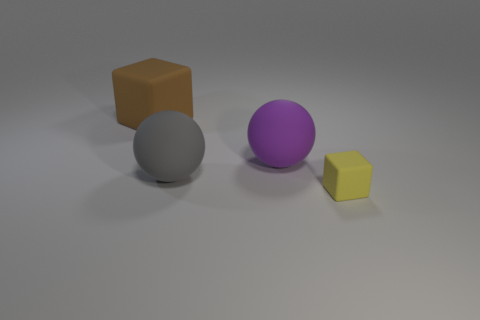Add 1 green metal cylinders. How many objects exist? 5 Subtract all purple balls. How many balls are left? 1 Subtract 1 spheres. How many spheres are left? 1 Add 4 rubber things. How many rubber things are left? 8 Add 1 cyan cylinders. How many cyan cylinders exist? 1 Subtract 0 yellow balls. How many objects are left? 4 Subtract all brown balls. Subtract all red blocks. How many balls are left? 2 Subtract all brown cylinders. How many cyan spheres are left? 0 Subtract all purple matte cylinders. Subtract all purple matte spheres. How many objects are left? 3 